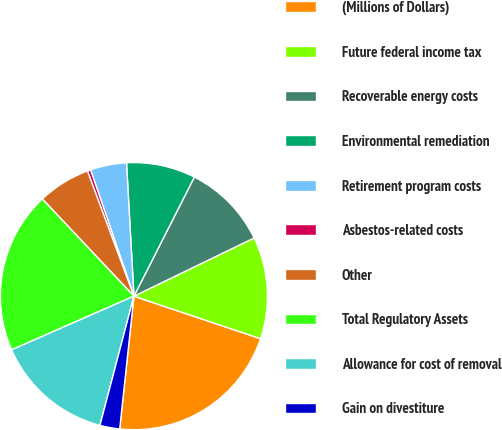<chart> <loc_0><loc_0><loc_500><loc_500><pie_chart><fcel>(Millions of Dollars)<fcel>Future federal income tax<fcel>Recoverable energy costs<fcel>Environmental remediation<fcel>Retirement program costs<fcel>Asbestos-related costs<fcel>Other<fcel>Total Regulatory Assets<fcel>Allowance for cost of removal<fcel>Gain on divestiture<nl><fcel>21.55%<fcel>12.34%<fcel>10.35%<fcel>8.36%<fcel>4.38%<fcel>0.4%<fcel>6.37%<fcel>19.56%<fcel>14.33%<fcel>2.39%<nl></chart> 